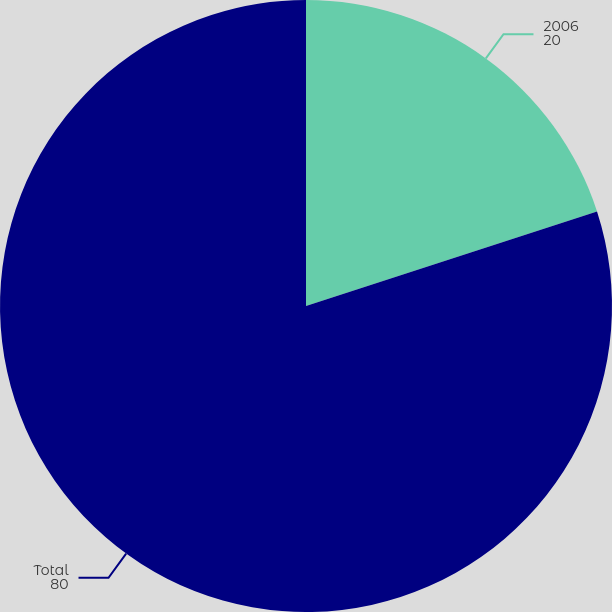<chart> <loc_0><loc_0><loc_500><loc_500><pie_chart><fcel>2006<fcel>Total<nl><fcel>20.0%<fcel>80.0%<nl></chart> 